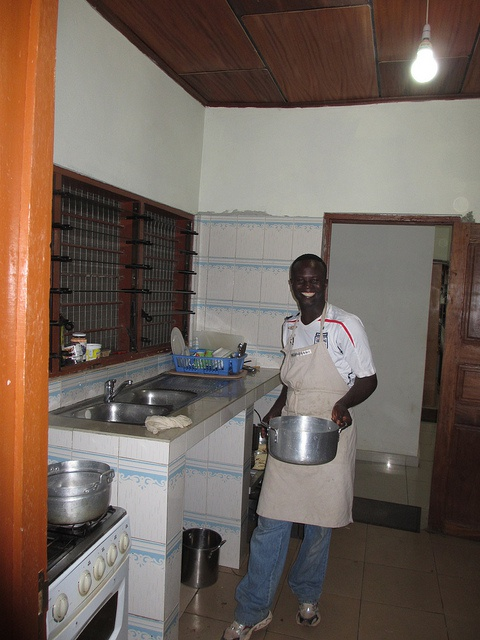Describe the objects in this image and their specific colors. I can see people in brown, darkgray, gray, black, and darkblue tones, oven in brown, darkgray, black, gray, and lightgray tones, sink in brown, black, and gray tones, bowl in brown, gray, darkgray, lightgray, and black tones, and bowl in brown, darkgray, and gray tones in this image. 